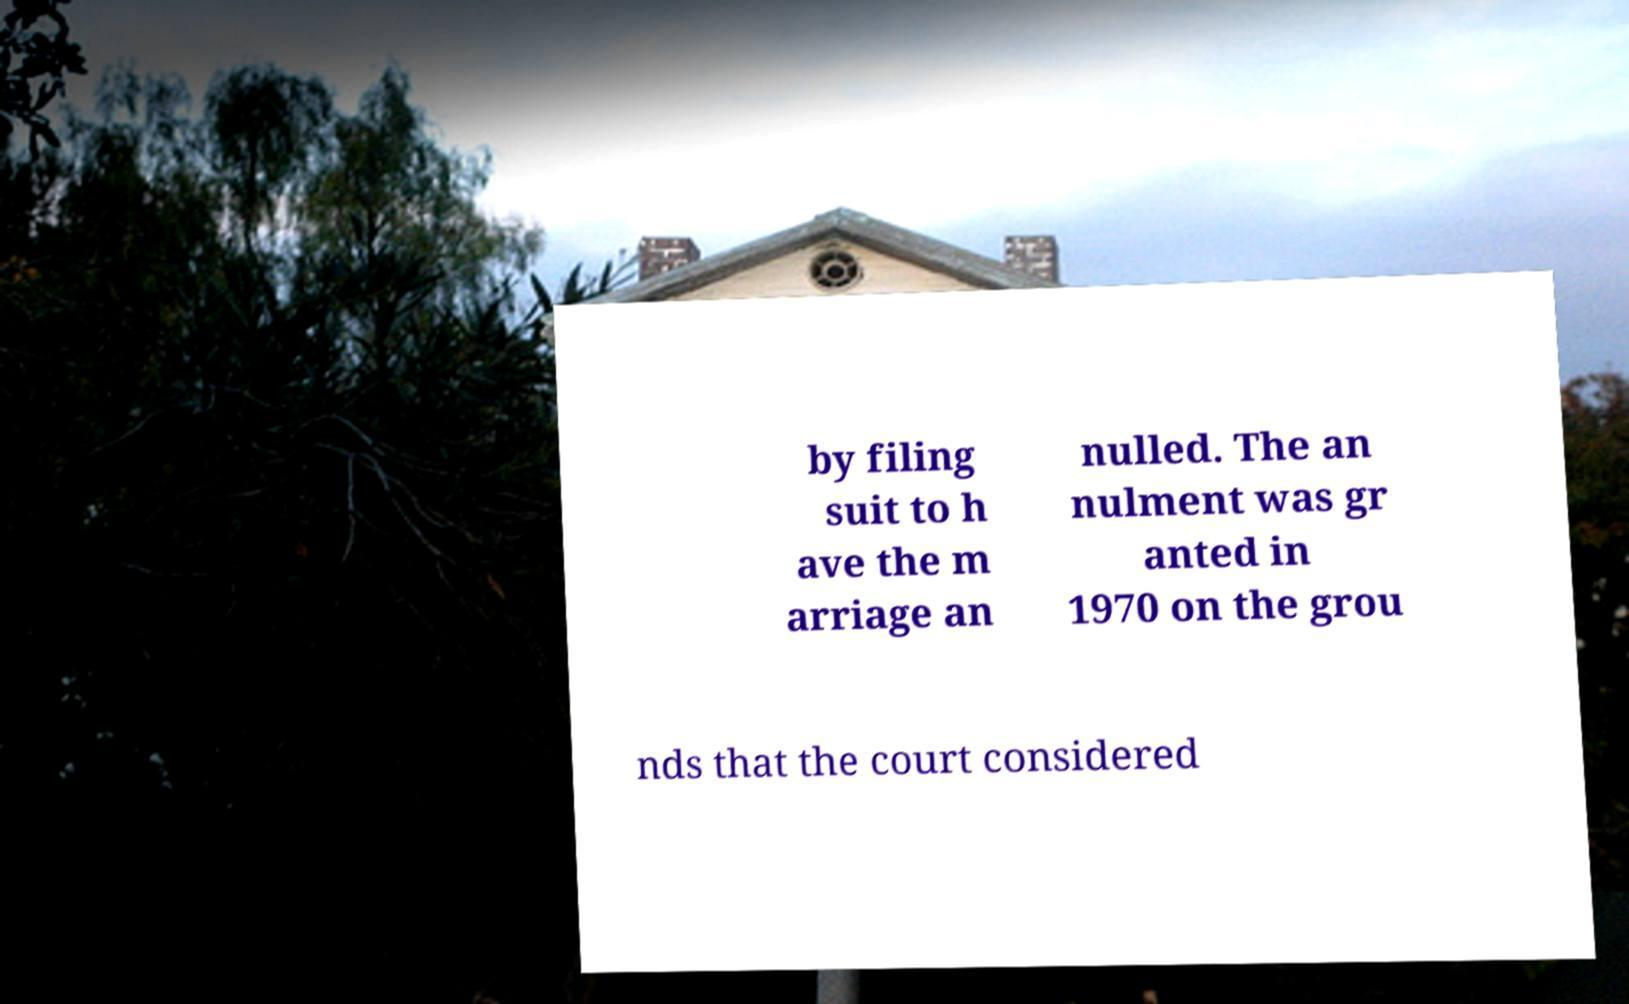Can you accurately transcribe the text from the provided image for me? by filing suit to h ave the m arriage an nulled. The an nulment was gr anted in 1970 on the grou nds that the court considered 